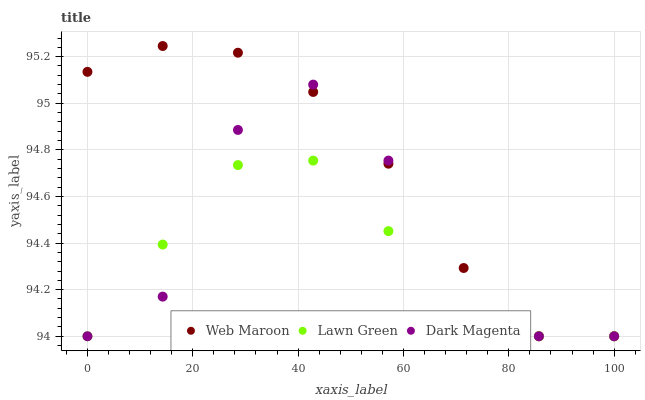Does Lawn Green have the minimum area under the curve?
Answer yes or no. Yes. Does Web Maroon have the maximum area under the curve?
Answer yes or no. Yes. Does Dark Magenta have the minimum area under the curve?
Answer yes or no. No. Does Dark Magenta have the maximum area under the curve?
Answer yes or no. No. Is Web Maroon the smoothest?
Answer yes or no. Yes. Is Dark Magenta the roughest?
Answer yes or no. Yes. Is Dark Magenta the smoothest?
Answer yes or no. No. Is Web Maroon the roughest?
Answer yes or no. No. Does Lawn Green have the lowest value?
Answer yes or no. Yes. Does Web Maroon have the highest value?
Answer yes or no. Yes. Does Dark Magenta have the highest value?
Answer yes or no. No. Does Lawn Green intersect Web Maroon?
Answer yes or no. Yes. Is Lawn Green less than Web Maroon?
Answer yes or no. No. Is Lawn Green greater than Web Maroon?
Answer yes or no. No. 